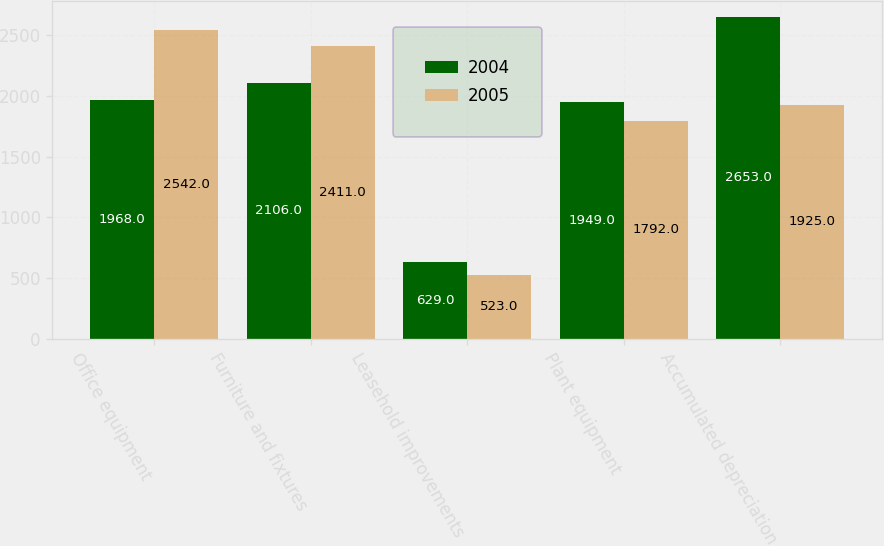<chart> <loc_0><loc_0><loc_500><loc_500><stacked_bar_chart><ecel><fcel>Office equipment<fcel>Furniture and fixtures<fcel>Leasehold improvements<fcel>Plant equipment<fcel>Accumulated depreciation<nl><fcel>2004<fcel>1968<fcel>2106<fcel>629<fcel>1949<fcel>2653<nl><fcel>2005<fcel>2542<fcel>2411<fcel>523<fcel>1792<fcel>1925<nl></chart> 